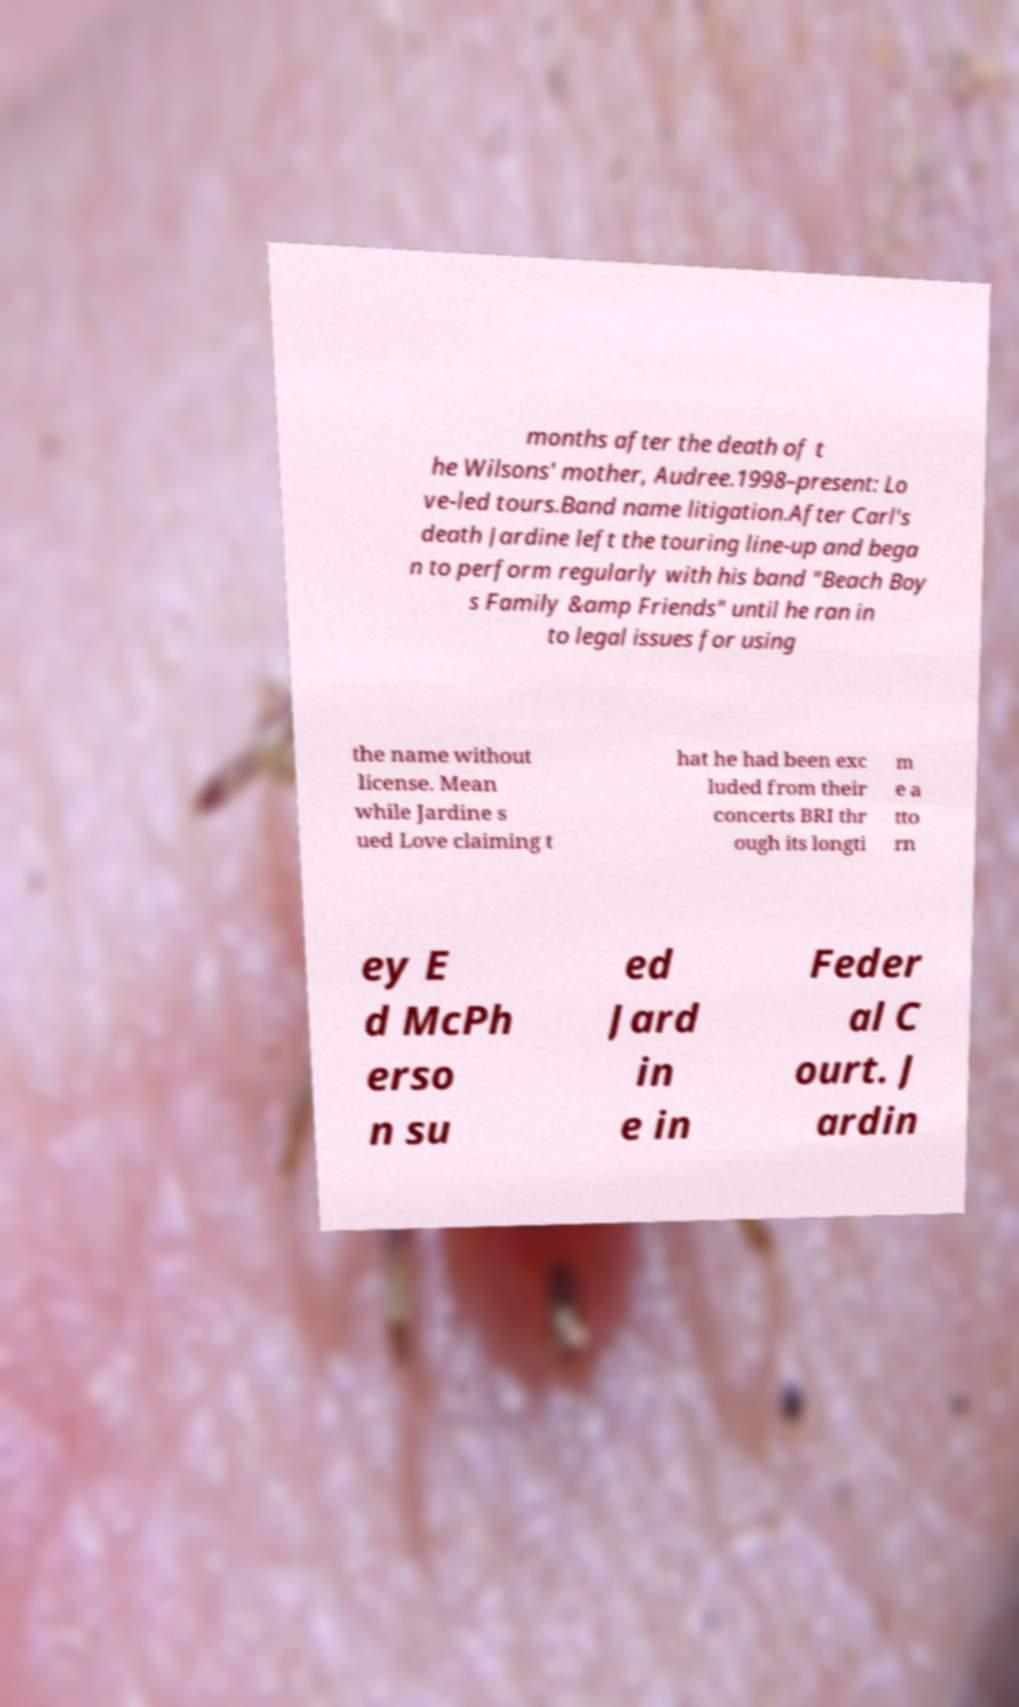What messages or text are displayed in this image? I need them in a readable, typed format. months after the death of t he Wilsons' mother, Audree.1998–present: Lo ve-led tours.Band name litigation.After Carl's death Jardine left the touring line-up and bega n to perform regularly with his band "Beach Boy s Family &amp Friends" until he ran in to legal issues for using the name without license. Mean while Jardine s ued Love claiming t hat he had been exc luded from their concerts BRI thr ough its longti m e a tto rn ey E d McPh erso n su ed Jard in e in Feder al C ourt. J ardin 